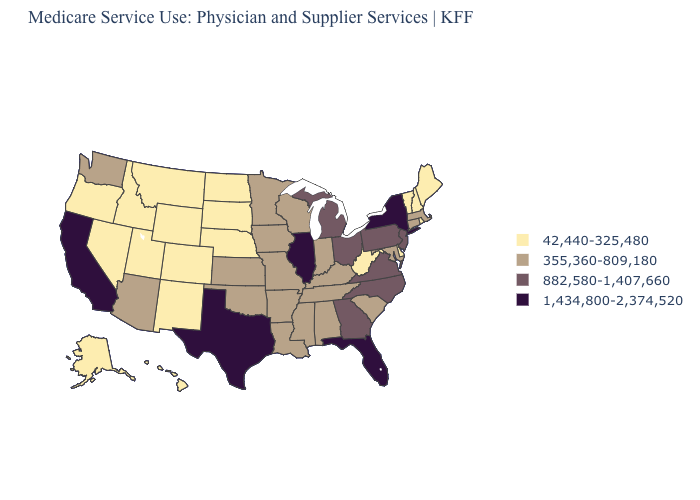Does Iowa have a higher value than California?
Write a very short answer. No. What is the value of Rhode Island?
Be succinct. 42,440-325,480. Does the first symbol in the legend represent the smallest category?
Be succinct. Yes. Does Kansas have the highest value in the MidWest?
Quick response, please. No. What is the value of North Carolina?
Quick response, please. 882,580-1,407,660. What is the value of Kentucky?
Keep it brief. 355,360-809,180. What is the value of Arizona?
Answer briefly. 355,360-809,180. What is the value of Vermont?
Write a very short answer. 42,440-325,480. Does Texas have the highest value in the USA?
Short answer required. Yes. Which states have the lowest value in the Northeast?
Answer briefly. Maine, New Hampshire, Rhode Island, Vermont. Which states have the lowest value in the South?
Give a very brief answer. Delaware, West Virginia. What is the lowest value in states that border Michigan?
Give a very brief answer. 355,360-809,180. Among the states that border Illinois , which have the lowest value?
Answer briefly. Indiana, Iowa, Kentucky, Missouri, Wisconsin. Name the states that have a value in the range 882,580-1,407,660?
Be succinct. Georgia, Michigan, New Jersey, North Carolina, Ohio, Pennsylvania, Virginia. 